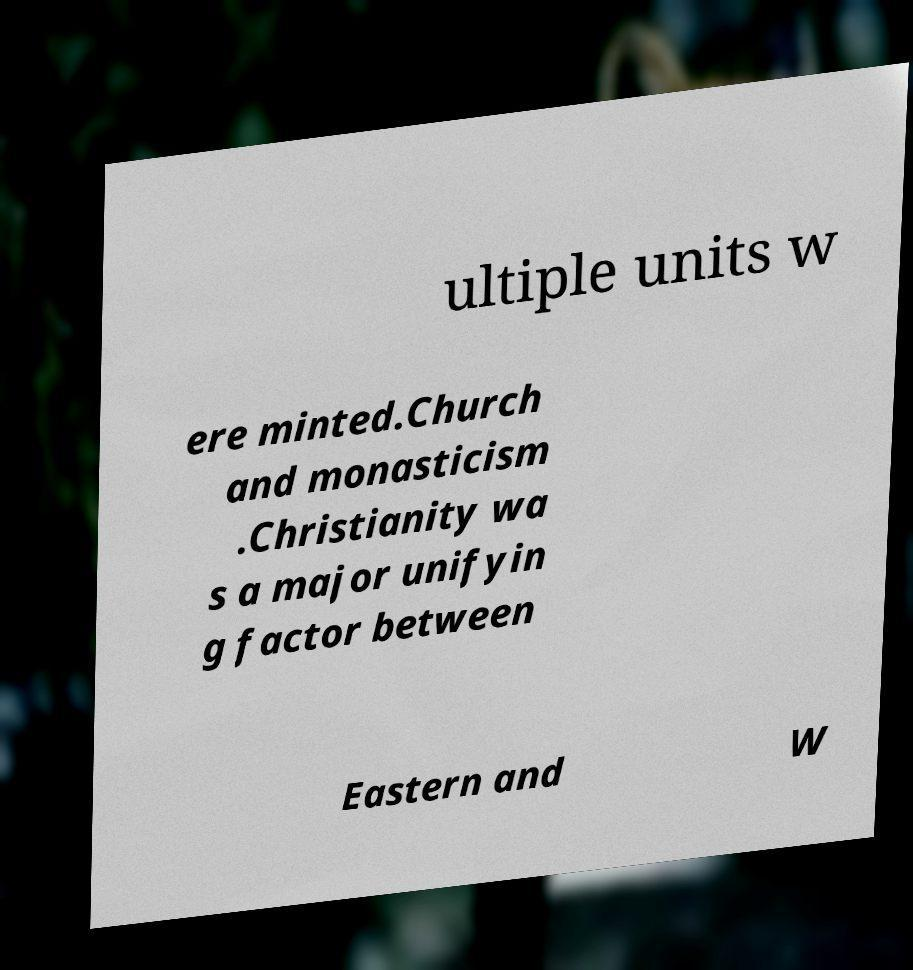Please read and relay the text visible in this image. What does it say? ultiple units w ere minted.Church and monasticism .Christianity wa s a major unifyin g factor between Eastern and W 